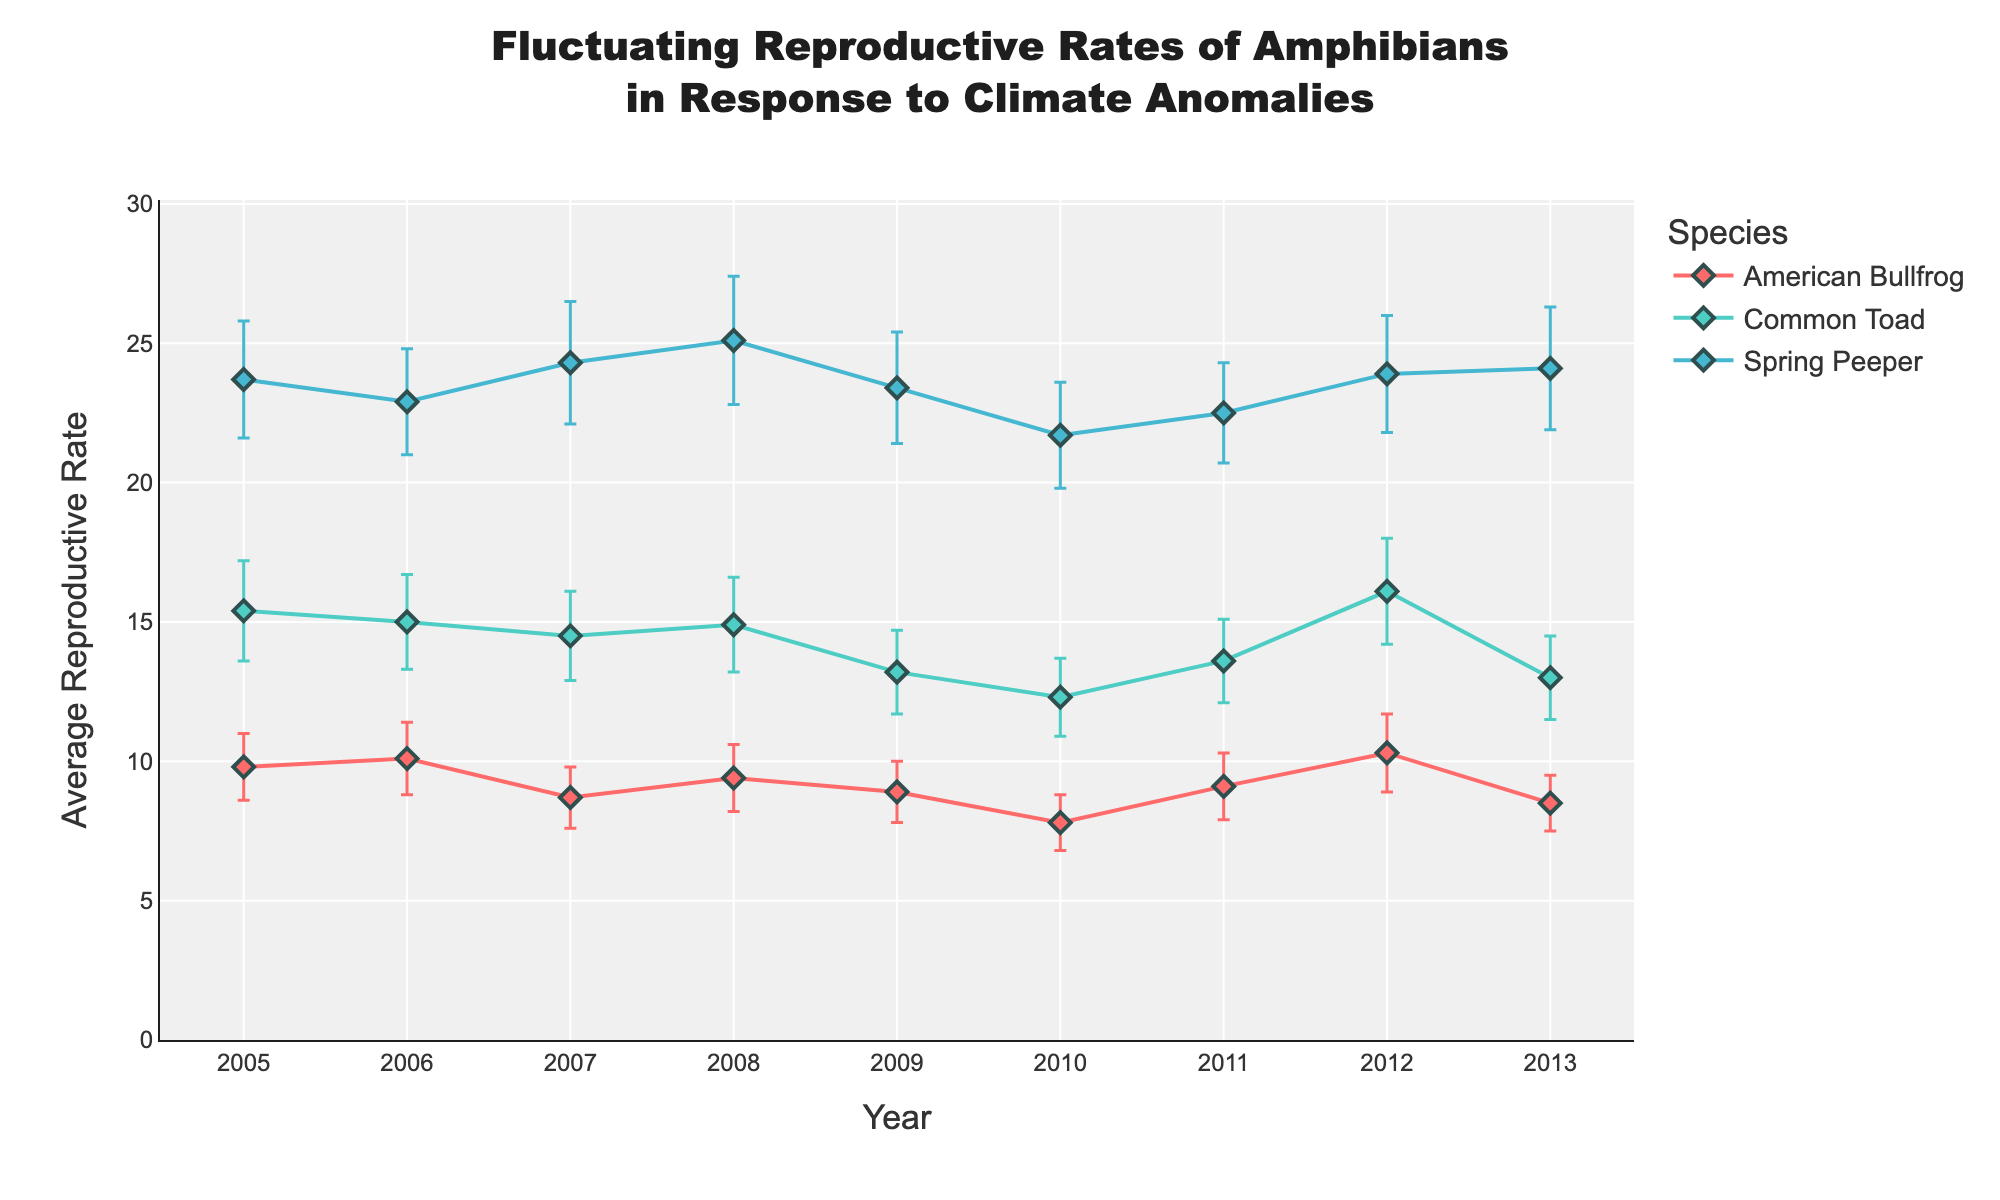What's the highest average reproductive rate reported for Spring Peeper? Look at the series for Spring Peeper and identify the highest point on the y-axis (Average Reproductive Rate). The highest value is 25.1 in the year 2008.
Answer: 25.1 Which species had the lowest average reproductive rate in 2010? Compare the average reproductive rates of American Bullfrog, Common Toad, and Spring Peeper in 2010. The American Bullfrog had 7.8, which is the lowest.
Answer: American Bullfrog How did the average reproductive rate for the Common Toad change from 2009 to 2010? Examine the values for the Common Toad in 2009 (13.2) and 2010 (12.3). Calculate the difference: 12.3 - 13.2 = -0.9.
Answer: Decreased by 0.9 What was the average and standard deviation for American Bullfrog in 2012? Identify the value points for American Bullfrog in 2012: Average Reproductive Rate is 10.3, Standard Deviation is 1.4.
Answer: Average: 10.3, Standard Deviation: 1.4 Which species has the most consistent reproductive rate, based on standard deviation over the years? Find the species with the lowest average standard deviation over the years. American Bullfrog has the lowest average standard deviation when summed and averaged.
Answer: American Bullfrog In which year did the Spring Peeper report its lowest average reproductive rate and what was that rate? Scan the values for Spring Peeper and identify the year with the lowest average reproductive rate. It's in 2010 with a rate of 21.7.
Answer: 2010, 21.7 Between 2005 and 2007, how did the average reproductive rate of American Bullfrog change? Look at the average reproductive rates for American Bullfrog in 2005 (9.8), 2006 (10.1), and 2007 (8.7). Calculate the overall change from 2005 to 2007: 8.7 - 9.8 = -1.1.
Answer: Decreased by 1.1 Which two species seem to have the closest average reproductive rates in 2008? Compare the average reproductive rates for all species in 2008: American Bullfrog (9.4), Common Toad (14.9), Spring Peeper (25.1). The closest rates are American Bullfrog and Common Toad.
Answer: American Bullfrog and Common Toad Considering error bars, which species showed the most variability in reproductive rate in 2011? Examine the standard deviations (length of error bars) for all species in 2011. Spring Peeper’s error bar is highest at 1.8.
Answer: Spring Peeper Does the Common Toad show an upward or downward trend in average reproductive rates from 2005 to 2013? Identify the trend line for Common Toad from 2005 to 2013. Starting at 15.4 and ending at 13. It shows a downward trend.
Answer: Downward 